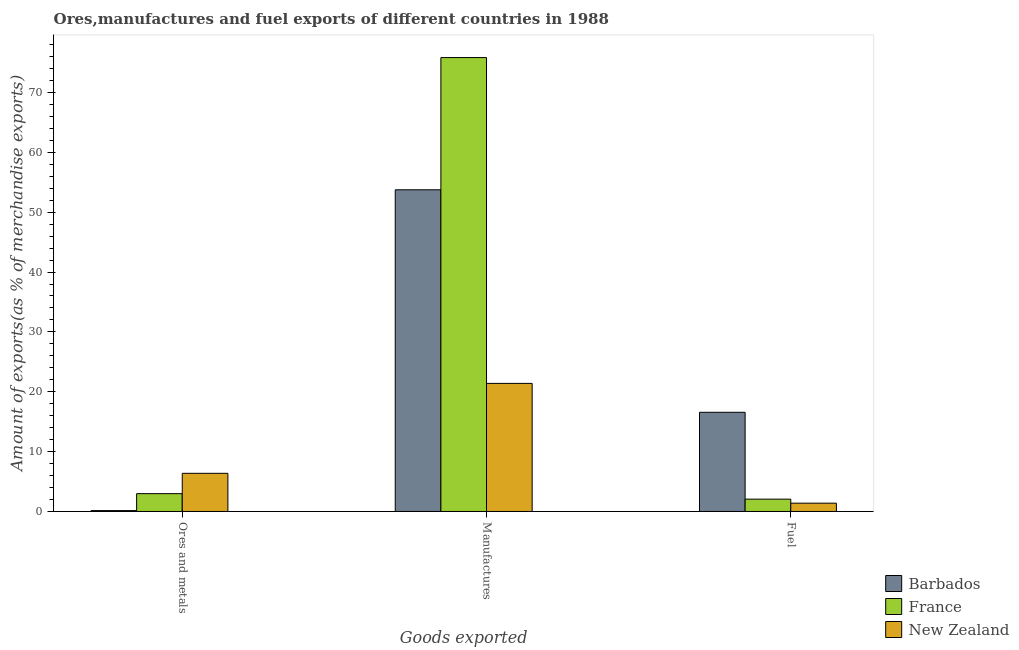How many different coloured bars are there?
Give a very brief answer. 3. How many groups of bars are there?
Offer a very short reply. 3. How many bars are there on the 3rd tick from the left?
Keep it short and to the point. 3. How many bars are there on the 1st tick from the right?
Your answer should be very brief. 3. What is the label of the 2nd group of bars from the left?
Provide a succinct answer. Manufactures. What is the percentage of fuel exports in New Zealand?
Keep it short and to the point. 1.39. Across all countries, what is the maximum percentage of manufactures exports?
Provide a short and direct response. 75.83. Across all countries, what is the minimum percentage of fuel exports?
Your answer should be very brief. 1.39. In which country was the percentage of manufactures exports maximum?
Give a very brief answer. France. In which country was the percentage of ores and metals exports minimum?
Make the answer very short. Barbados. What is the total percentage of ores and metals exports in the graph?
Provide a short and direct response. 9.5. What is the difference between the percentage of fuel exports in Barbados and that in France?
Your answer should be compact. 14.51. What is the difference between the percentage of manufactures exports in France and the percentage of ores and metals exports in Barbados?
Give a very brief answer. 75.68. What is the average percentage of ores and metals exports per country?
Give a very brief answer. 3.17. What is the difference between the percentage of ores and metals exports and percentage of fuel exports in Barbados?
Give a very brief answer. -16.42. What is the ratio of the percentage of manufactures exports in France to that in Barbados?
Keep it short and to the point. 1.41. Is the percentage of ores and metals exports in France less than that in Barbados?
Offer a very short reply. No. What is the difference between the highest and the second highest percentage of manufactures exports?
Your answer should be compact. 22.09. What is the difference between the highest and the lowest percentage of fuel exports?
Provide a succinct answer. 15.18. In how many countries, is the percentage of fuel exports greater than the average percentage of fuel exports taken over all countries?
Offer a very short reply. 1. How many bars are there?
Your response must be concise. 9. Does the graph contain any zero values?
Keep it short and to the point. No. Does the graph contain grids?
Your answer should be very brief. No. How many legend labels are there?
Provide a short and direct response. 3. What is the title of the graph?
Ensure brevity in your answer.  Ores,manufactures and fuel exports of different countries in 1988. What is the label or title of the X-axis?
Make the answer very short. Goods exported. What is the label or title of the Y-axis?
Make the answer very short. Amount of exports(as % of merchandise exports). What is the Amount of exports(as % of merchandise exports) in Barbados in Ores and metals?
Ensure brevity in your answer.  0.15. What is the Amount of exports(as % of merchandise exports) in France in Ores and metals?
Offer a very short reply. 2.98. What is the Amount of exports(as % of merchandise exports) of New Zealand in Ores and metals?
Your response must be concise. 6.38. What is the Amount of exports(as % of merchandise exports) in Barbados in Manufactures?
Your answer should be compact. 53.74. What is the Amount of exports(as % of merchandise exports) of France in Manufactures?
Your answer should be compact. 75.83. What is the Amount of exports(as % of merchandise exports) of New Zealand in Manufactures?
Give a very brief answer. 21.4. What is the Amount of exports(as % of merchandise exports) in Barbados in Fuel?
Offer a very short reply. 16.57. What is the Amount of exports(as % of merchandise exports) in France in Fuel?
Your answer should be compact. 2.06. What is the Amount of exports(as % of merchandise exports) of New Zealand in Fuel?
Offer a very short reply. 1.39. Across all Goods exported, what is the maximum Amount of exports(as % of merchandise exports) of Barbados?
Offer a terse response. 53.74. Across all Goods exported, what is the maximum Amount of exports(as % of merchandise exports) in France?
Your answer should be compact. 75.83. Across all Goods exported, what is the maximum Amount of exports(as % of merchandise exports) of New Zealand?
Provide a succinct answer. 21.4. Across all Goods exported, what is the minimum Amount of exports(as % of merchandise exports) of Barbados?
Provide a succinct answer. 0.15. Across all Goods exported, what is the minimum Amount of exports(as % of merchandise exports) in France?
Your response must be concise. 2.06. Across all Goods exported, what is the minimum Amount of exports(as % of merchandise exports) of New Zealand?
Offer a terse response. 1.39. What is the total Amount of exports(as % of merchandise exports) in Barbados in the graph?
Your response must be concise. 70.46. What is the total Amount of exports(as % of merchandise exports) of France in the graph?
Provide a short and direct response. 80.87. What is the total Amount of exports(as % of merchandise exports) of New Zealand in the graph?
Keep it short and to the point. 29.16. What is the difference between the Amount of exports(as % of merchandise exports) in Barbados in Ores and metals and that in Manufactures?
Your response must be concise. -53.59. What is the difference between the Amount of exports(as % of merchandise exports) of France in Ores and metals and that in Manufactures?
Your response must be concise. -72.85. What is the difference between the Amount of exports(as % of merchandise exports) of New Zealand in Ores and metals and that in Manufactures?
Make the answer very short. -15.02. What is the difference between the Amount of exports(as % of merchandise exports) in Barbados in Ores and metals and that in Fuel?
Offer a very short reply. -16.42. What is the difference between the Amount of exports(as % of merchandise exports) in France in Ores and metals and that in Fuel?
Give a very brief answer. 0.92. What is the difference between the Amount of exports(as % of merchandise exports) in New Zealand in Ores and metals and that in Fuel?
Provide a succinct answer. 4.99. What is the difference between the Amount of exports(as % of merchandise exports) of Barbados in Manufactures and that in Fuel?
Offer a very short reply. 37.17. What is the difference between the Amount of exports(as % of merchandise exports) in France in Manufactures and that in Fuel?
Your answer should be compact. 73.76. What is the difference between the Amount of exports(as % of merchandise exports) of New Zealand in Manufactures and that in Fuel?
Offer a very short reply. 20.01. What is the difference between the Amount of exports(as % of merchandise exports) of Barbados in Ores and metals and the Amount of exports(as % of merchandise exports) of France in Manufactures?
Ensure brevity in your answer.  -75.68. What is the difference between the Amount of exports(as % of merchandise exports) of Barbados in Ores and metals and the Amount of exports(as % of merchandise exports) of New Zealand in Manufactures?
Offer a very short reply. -21.25. What is the difference between the Amount of exports(as % of merchandise exports) in France in Ores and metals and the Amount of exports(as % of merchandise exports) in New Zealand in Manufactures?
Your response must be concise. -18.42. What is the difference between the Amount of exports(as % of merchandise exports) in Barbados in Ores and metals and the Amount of exports(as % of merchandise exports) in France in Fuel?
Provide a succinct answer. -1.91. What is the difference between the Amount of exports(as % of merchandise exports) in Barbados in Ores and metals and the Amount of exports(as % of merchandise exports) in New Zealand in Fuel?
Make the answer very short. -1.24. What is the difference between the Amount of exports(as % of merchandise exports) of France in Ores and metals and the Amount of exports(as % of merchandise exports) of New Zealand in Fuel?
Keep it short and to the point. 1.59. What is the difference between the Amount of exports(as % of merchandise exports) of Barbados in Manufactures and the Amount of exports(as % of merchandise exports) of France in Fuel?
Your response must be concise. 51.68. What is the difference between the Amount of exports(as % of merchandise exports) of Barbados in Manufactures and the Amount of exports(as % of merchandise exports) of New Zealand in Fuel?
Your answer should be very brief. 52.35. What is the difference between the Amount of exports(as % of merchandise exports) of France in Manufactures and the Amount of exports(as % of merchandise exports) of New Zealand in Fuel?
Keep it short and to the point. 74.44. What is the average Amount of exports(as % of merchandise exports) of Barbados per Goods exported?
Make the answer very short. 23.49. What is the average Amount of exports(as % of merchandise exports) in France per Goods exported?
Ensure brevity in your answer.  26.96. What is the average Amount of exports(as % of merchandise exports) in New Zealand per Goods exported?
Keep it short and to the point. 9.72. What is the difference between the Amount of exports(as % of merchandise exports) of Barbados and Amount of exports(as % of merchandise exports) of France in Ores and metals?
Provide a succinct answer. -2.83. What is the difference between the Amount of exports(as % of merchandise exports) of Barbados and Amount of exports(as % of merchandise exports) of New Zealand in Ores and metals?
Your answer should be very brief. -6.23. What is the difference between the Amount of exports(as % of merchandise exports) in France and Amount of exports(as % of merchandise exports) in New Zealand in Ores and metals?
Offer a very short reply. -3.39. What is the difference between the Amount of exports(as % of merchandise exports) in Barbados and Amount of exports(as % of merchandise exports) in France in Manufactures?
Your answer should be compact. -22.09. What is the difference between the Amount of exports(as % of merchandise exports) of Barbados and Amount of exports(as % of merchandise exports) of New Zealand in Manufactures?
Your answer should be compact. 32.34. What is the difference between the Amount of exports(as % of merchandise exports) in France and Amount of exports(as % of merchandise exports) in New Zealand in Manufactures?
Provide a succinct answer. 54.43. What is the difference between the Amount of exports(as % of merchandise exports) in Barbados and Amount of exports(as % of merchandise exports) in France in Fuel?
Offer a terse response. 14.51. What is the difference between the Amount of exports(as % of merchandise exports) of Barbados and Amount of exports(as % of merchandise exports) of New Zealand in Fuel?
Give a very brief answer. 15.18. What is the difference between the Amount of exports(as % of merchandise exports) in France and Amount of exports(as % of merchandise exports) in New Zealand in Fuel?
Offer a terse response. 0.67. What is the ratio of the Amount of exports(as % of merchandise exports) of Barbados in Ores and metals to that in Manufactures?
Your response must be concise. 0. What is the ratio of the Amount of exports(as % of merchandise exports) of France in Ores and metals to that in Manufactures?
Your answer should be very brief. 0.04. What is the ratio of the Amount of exports(as % of merchandise exports) of New Zealand in Ores and metals to that in Manufactures?
Keep it short and to the point. 0.3. What is the ratio of the Amount of exports(as % of merchandise exports) of Barbados in Ores and metals to that in Fuel?
Provide a short and direct response. 0.01. What is the ratio of the Amount of exports(as % of merchandise exports) of France in Ores and metals to that in Fuel?
Offer a terse response. 1.45. What is the ratio of the Amount of exports(as % of merchandise exports) in New Zealand in Ores and metals to that in Fuel?
Your answer should be compact. 4.59. What is the ratio of the Amount of exports(as % of merchandise exports) of Barbados in Manufactures to that in Fuel?
Provide a short and direct response. 3.24. What is the ratio of the Amount of exports(as % of merchandise exports) in France in Manufactures to that in Fuel?
Your answer should be very brief. 36.79. What is the ratio of the Amount of exports(as % of merchandise exports) of New Zealand in Manufactures to that in Fuel?
Ensure brevity in your answer.  15.41. What is the difference between the highest and the second highest Amount of exports(as % of merchandise exports) in Barbados?
Your answer should be compact. 37.17. What is the difference between the highest and the second highest Amount of exports(as % of merchandise exports) of France?
Your response must be concise. 72.85. What is the difference between the highest and the second highest Amount of exports(as % of merchandise exports) of New Zealand?
Your answer should be compact. 15.02. What is the difference between the highest and the lowest Amount of exports(as % of merchandise exports) in Barbados?
Provide a succinct answer. 53.59. What is the difference between the highest and the lowest Amount of exports(as % of merchandise exports) of France?
Keep it short and to the point. 73.76. What is the difference between the highest and the lowest Amount of exports(as % of merchandise exports) of New Zealand?
Your answer should be compact. 20.01. 